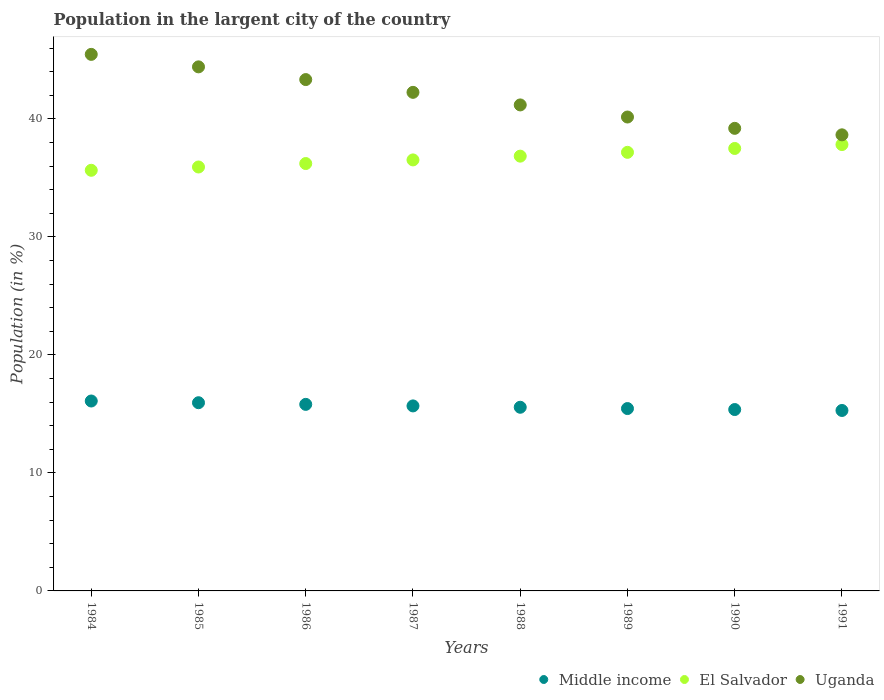What is the percentage of population in the largent city in Middle income in 1987?
Ensure brevity in your answer.  15.68. Across all years, what is the maximum percentage of population in the largent city in Middle income?
Your response must be concise. 16.1. Across all years, what is the minimum percentage of population in the largent city in Uganda?
Offer a very short reply. 38.65. In which year was the percentage of population in the largent city in El Salvador minimum?
Offer a terse response. 1984. What is the total percentage of population in the largent city in Uganda in the graph?
Ensure brevity in your answer.  334.69. What is the difference between the percentage of population in the largent city in El Salvador in 1984 and that in 1990?
Your answer should be very brief. -1.85. What is the difference between the percentage of population in the largent city in Uganda in 1984 and the percentage of population in the largent city in Middle income in 1988?
Make the answer very short. 29.91. What is the average percentage of population in the largent city in Uganda per year?
Give a very brief answer. 41.84. In the year 1987, what is the difference between the percentage of population in the largent city in Uganda and percentage of population in the largent city in Middle income?
Give a very brief answer. 26.57. What is the ratio of the percentage of population in the largent city in Uganda in 1985 to that in 1989?
Make the answer very short. 1.11. What is the difference between the highest and the second highest percentage of population in the largent city in El Salvador?
Offer a terse response. 0.33. What is the difference between the highest and the lowest percentage of population in the largent city in Uganda?
Your response must be concise. 6.82. In how many years, is the percentage of population in the largent city in El Salvador greater than the average percentage of population in the largent city in El Salvador taken over all years?
Ensure brevity in your answer.  4. How many years are there in the graph?
Make the answer very short. 8. What is the difference between two consecutive major ticks on the Y-axis?
Offer a very short reply. 10. Does the graph contain any zero values?
Your answer should be compact. No. Does the graph contain grids?
Offer a terse response. No. Where does the legend appear in the graph?
Offer a very short reply. Bottom right. How many legend labels are there?
Keep it short and to the point. 3. What is the title of the graph?
Your answer should be compact. Population in the largent city of the country. What is the Population (in %) in Middle income in 1984?
Provide a succinct answer. 16.1. What is the Population (in %) of El Salvador in 1984?
Offer a terse response. 35.65. What is the Population (in %) of Uganda in 1984?
Offer a terse response. 45.47. What is the Population (in %) in Middle income in 1985?
Provide a short and direct response. 15.95. What is the Population (in %) in El Salvador in 1985?
Give a very brief answer. 35.93. What is the Population (in %) of Uganda in 1985?
Offer a terse response. 44.41. What is the Population (in %) in Middle income in 1986?
Ensure brevity in your answer.  15.81. What is the Population (in %) of El Salvador in 1986?
Offer a very short reply. 36.22. What is the Population (in %) of Uganda in 1986?
Keep it short and to the point. 43.34. What is the Population (in %) of Middle income in 1987?
Provide a short and direct response. 15.68. What is the Population (in %) in El Salvador in 1987?
Keep it short and to the point. 36.53. What is the Population (in %) of Uganda in 1987?
Make the answer very short. 42.25. What is the Population (in %) in Middle income in 1988?
Your answer should be compact. 15.57. What is the Population (in %) of El Salvador in 1988?
Keep it short and to the point. 36.85. What is the Population (in %) of Uganda in 1988?
Ensure brevity in your answer.  41.19. What is the Population (in %) of Middle income in 1989?
Provide a short and direct response. 15.46. What is the Population (in %) in El Salvador in 1989?
Your answer should be very brief. 37.17. What is the Population (in %) of Uganda in 1989?
Provide a succinct answer. 40.16. What is the Population (in %) of Middle income in 1990?
Your answer should be very brief. 15.37. What is the Population (in %) of El Salvador in 1990?
Your answer should be compact. 37.5. What is the Population (in %) in Uganda in 1990?
Give a very brief answer. 39.2. What is the Population (in %) in Middle income in 1991?
Offer a very short reply. 15.29. What is the Population (in %) in El Salvador in 1991?
Ensure brevity in your answer.  37.83. What is the Population (in %) of Uganda in 1991?
Offer a terse response. 38.65. Across all years, what is the maximum Population (in %) of Middle income?
Your answer should be very brief. 16.1. Across all years, what is the maximum Population (in %) in El Salvador?
Your answer should be very brief. 37.83. Across all years, what is the maximum Population (in %) in Uganda?
Provide a succinct answer. 45.47. Across all years, what is the minimum Population (in %) in Middle income?
Offer a very short reply. 15.29. Across all years, what is the minimum Population (in %) of El Salvador?
Your answer should be compact. 35.65. Across all years, what is the minimum Population (in %) in Uganda?
Offer a very short reply. 38.65. What is the total Population (in %) in Middle income in the graph?
Offer a very short reply. 125.22. What is the total Population (in %) of El Salvador in the graph?
Provide a succinct answer. 293.67. What is the total Population (in %) of Uganda in the graph?
Ensure brevity in your answer.  334.69. What is the difference between the Population (in %) in Middle income in 1984 and that in 1985?
Offer a very short reply. 0.14. What is the difference between the Population (in %) in El Salvador in 1984 and that in 1985?
Offer a very short reply. -0.28. What is the difference between the Population (in %) in Uganda in 1984 and that in 1985?
Give a very brief answer. 1.06. What is the difference between the Population (in %) of Middle income in 1984 and that in 1986?
Give a very brief answer. 0.28. What is the difference between the Population (in %) in El Salvador in 1984 and that in 1986?
Provide a succinct answer. -0.57. What is the difference between the Population (in %) in Uganda in 1984 and that in 1986?
Provide a succinct answer. 2.14. What is the difference between the Population (in %) in Middle income in 1984 and that in 1987?
Keep it short and to the point. 0.42. What is the difference between the Population (in %) of El Salvador in 1984 and that in 1987?
Ensure brevity in your answer.  -0.88. What is the difference between the Population (in %) in Uganda in 1984 and that in 1987?
Keep it short and to the point. 3.22. What is the difference between the Population (in %) in Middle income in 1984 and that in 1988?
Offer a very short reply. 0.53. What is the difference between the Population (in %) of El Salvador in 1984 and that in 1988?
Provide a short and direct response. -1.2. What is the difference between the Population (in %) of Uganda in 1984 and that in 1988?
Your answer should be compact. 4.28. What is the difference between the Population (in %) in Middle income in 1984 and that in 1989?
Provide a short and direct response. 0.64. What is the difference between the Population (in %) of El Salvador in 1984 and that in 1989?
Give a very brief answer. -1.52. What is the difference between the Population (in %) of Uganda in 1984 and that in 1989?
Offer a very short reply. 5.31. What is the difference between the Population (in %) in Middle income in 1984 and that in 1990?
Offer a terse response. 0.72. What is the difference between the Population (in %) in El Salvador in 1984 and that in 1990?
Make the answer very short. -1.85. What is the difference between the Population (in %) of Uganda in 1984 and that in 1990?
Give a very brief answer. 6.27. What is the difference between the Population (in %) of Middle income in 1984 and that in 1991?
Ensure brevity in your answer.  0.8. What is the difference between the Population (in %) of El Salvador in 1984 and that in 1991?
Ensure brevity in your answer.  -2.18. What is the difference between the Population (in %) of Uganda in 1984 and that in 1991?
Give a very brief answer. 6.82. What is the difference between the Population (in %) in Middle income in 1985 and that in 1986?
Offer a very short reply. 0.14. What is the difference between the Population (in %) in El Salvador in 1985 and that in 1986?
Your answer should be compact. -0.29. What is the difference between the Population (in %) of Uganda in 1985 and that in 1986?
Provide a succinct answer. 1.08. What is the difference between the Population (in %) of Middle income in 1985 and that in 1987?
Make the answer very short. 0.27. What is the difference between the Population (in %) in El Salvador in 1985 and that in 1987?
Ensure brevity in your answer.  -0.6. What is the difference between the Population (in %) of Uganda in 1985 and that in 1987?
Offer a terse response. 2.16. What is the difference between the Population (in %) in Middle income in 1985 and that in 1988?
Your answer should be compact. 0.38. What is the difference between the Population (in %) of El Salvador in 1985 and that in 1988?
Keep it short and to the point. -0.92. What is the difference between the Population (in %) in Uganda in 1985 and that in 1988?
Give a very brief answer. 3.23. What is the difference between the Population (in %) in Middle income in 1985 and that in 1989?
Provide a succinct answer. 0.49. What is the difference between the Population (in %) of El Salvador in 1985 and that in 1989?
Provide a short and direct response. -1.24. What is the difference between the Population (in %) in Uganda in 1985 and that in 1989?
Your answer should be compact. 4.25. What is the difference between the Population (in %) of Middle income in 1985 and that in 1990?
Make the answer very short. 0.58. What is the difference between the Population (in %) in El Salvador in 1985 and that in 1990?
Offer a very short reply. -1.57. What is the difference between the Population (in %) in Uganda in 1985 and that in 1990?
Keep it short and to the point. 5.21. What is the difference between the Population (in %) in Middle income in 1985 and that in 1991?
Offer a terse response. 0.66. What is the difference between the Population (in %) of El Salvador in 1985 and that in 1991?
Provide a short and direct response. -1.9. What is the difference between the Population (in %) of Uganda in 1985 and that in 1991?
Ensure brevity in your answer.  5.76. What is the difference between the Population (in %) of Middle income in 1986 and that in 1987?
Provide a succinct answer. 0.13. What is the difference between the Population (in %) of El Salvador in 1986 and that in 1987?
Provide a succinct answer. -0.31. What is the difference between the Population (in %) in Uganda in 1986 and that in 1987?
Keep it short and to the point. 1.08. What is the difference between the Population (in %) of Middle income in 1986 and that in 1988?
Provide a succinct answer. 0.24. What is the difference between the Population (in %) in El Salvador in 1986 and that in 1988?
Offer a terse response. -0.63. What is the difference between the Population (in %) of Uganda in 1986 and that in 1988?
Keep it short and to the point. 2.15. What is the difference between the Population (in %) of Middle income in 1986 and that in 1989?
Make the answer very short. 0.35. What is the difference between the Population (in %) of El Salvador in 1986 and that in 1989?
Make the answer very short. -0.95. What is the difference between the Population (in %) in Uganda in 1986 and that in 1989?
Your answer should be compact. 3.17. What is the difference between the Population (in %) in Middle income in 1986 and that in 1990?
Your answer should be very brief. 0.44. What is the difference between the Population (in %) of El Salvador in 1986 and that in 1990?
Your answer should be very brief. -1.28. What is the difference between the Population (in %) in Uganda in 1986 and that in 1990?
Make the answer very short. 4.13. What is the difference between the Population (in %) in Middle income in 1986 and that in 1991?
Offer a very short reply. 0.52. What is the difference between the Population (in %) in El Salvador in 1986 and that in 1991?
Provide a short and direct response. -1.61. What is the difference between the Population (in %) in Uganda in 1986 and that in 1991?
Provide a succinct answer. 4.68. What is the difference between the Population (in %) of Middle income in 1987 and that in 1988?
Your response must be concise. 0.11. What is the difference between the Population (in %) in El Salvador in 1987 and that in 1988?
Provide a succinct answer. -0.32. What is the difference between the Population (in %) in Uganda in 1987 and that in 1988?
Provide a succinct answer. 1.07. What is the difference between the Population (in %) of Middle income in 1987 and that in 1989?
Keep it short and to the point. 0.22. What is the difference between the Population (in %) in El Salvador in 1987 and that in 1989?
Provide a short and direct response. -0.64. What is the difference between the Population (in %) in Uganda in 1987 and that in 1989?
Your answer should be compact. 2.09. What is the difference between the Population (in %) in Middle income in 1987 and that in 1990?
Your response must be concise. 0.31. What is the difference between the Population (in %) in El Salvador in 1987 and that in 1990?
Ensure brevity in your answer.  -0.97. What is the difference between the Population (in %) in Uganda in 1987 and that in 1990?
Ensure brevity in your answer.  3.05. What is the difference between the Population (in %) in Middle income in 1987 and that in 1991?
Provide a short and direct response. 0.39. What is the difference between the Population (in %) in El Salvador in 1987 and that in 1991?
Your answer should be very brief. -1.3. What is the difference between the Population (in %) of Uganda in 1987 and that in 1991?
Your response must be concise. 3.6. What is the difference between the Population (in %) in Middle income in 1988 and that in 1989?
Provide a succinct answer. 0.11. What is the difference between the Population (in %) in El Salvador in 1988 and that in 1989?
Your answer should be very brief. -0.32. What is the difference between the Population (in %) in Uganda in 1988 and that in 1989?
Ensure brevity in your answer.  1.02. What is the difference between the Population (in %) in Middle income in 1988 and that in 1990?
Provide a short and direct response. 0.19. What is the difference between the Population (in %) in El Salvador in 1988 and that in 1990?
Offer a very short reply. -0.65. What is the difference between the Population (in %) in Uganda in 1988 and that in 1990?
Make the answer very short. 1.98. What is the difference between the Population (in %) in Middle income in 1988 and that in 1991?
Ensure brevity in your answer.  0.27. What is the difference between the Population (in %) in El Salvador in 1988 and that in 1991?
Make the answer very short. -0.98. What is the difference between the Population (in %) in Uganda in 1988 and that in 1991?
Provide a succinct answer. 2.53. What is the difference between the Population (in %) of Middle income in 1989 and that in 1990?
Your response must be concise. 0.08. What is the difference between the Population (in %) of El Salvador in 1989 and that in 1990?
Ensure brevity in your answer.  -0.33. What is the difference between the Population (in %) in Uganda in 1989 and that in 1990?
Provide a succinct answer. 0.96. What is the difference between the Population (in %) of Middle income in 1989 and that in 1991?
Ensure brevity in your answer.  0.16. What is the difference between the Population (in %) of El Salvador in 1989 and that in 1991?
Your answer should be very brief. -0.66. What is the difference between the Population (in %) in Uganda in 1989 and that in 1991?
Your answer should be very brief. 1.51. What is the difference between the Population (in %) of Middle income in 1990 and that in 1991?
Your answer should be compact. 0.08. What is the difference between the Population (in %) in El Salvador in 1990 and that in 1991?
Give a very brief answer. -0.33. What is the difference between the Population (in %) of Uganda in 1990 and that in 1991?
Make the answer very short. 0.55. What is the difference between the Population (in %) of Middle income in 1984 and the Population (in %) of El Salvador in 1985?
Your response must be concise. -19.83. What is the difference between the Population (in %) of Middle income in 1984 and the Population (in %) of Uganda in 1985?
Keep it short and to the point. -28.32. What is the difference between the Population (in %) of El Salvador in 1984 and the Population (in %) of Uganda in 1985?
Make the answer very short. -8.77. What is the difference between the Population (in %) of Middle income in 1984 and the Population (in %) of El Salvador in 1986?
Offer a terse response. -20.13. What is the difference between the Population (in %) of Middle income in 1984 and the Population (in %) of Uganda in 1986?
Offer a very short reply. -27.24. What is the difference between the Population (in %) of El Salvador in 1984 and the Population (in %) of Uganda in 1986?
Provide a short and direct response. -7.69. What is the difference between the Population (in %) of Middle income in 1984 and the Population (in %) of El Salvador in 1987?
Provide a short and direct response. -20.43. What is the difference between the Population (in %) of Middle income in 1984 and the Population (in %) of Uganda in 1987?
Provide a short and direct response. -26.16. What is the difference between the Population (in %) of El Salvador in 1984 and the Population (in %) of Uganda in 1987?
Provide a short and direct response. -6.61. What is the difference between the Population (in %) of Middle income in 1984 and the Population (in %) of El Salvador in 1988?
Your answer should be compact. -20.75. What is the difference between the Population (in %) of Middle income in 1984 and the Population (in %) of Uganda in 1988?
Offer a very short reply. -25.09. What is the difference between the Population (in %) of El Salvador in 1984 and the Population (in %) of Uganda in 1988?
Your response must be concise. -5.54. What is the difference between the Population (in %) of Middle income in 1984 and the Population (in %) of El Salvador in 1989?
Your response must be concise. -21.08. What is the difference between the Population (in %) of Middle income in 1984 and the Population (in %) of Uganda in 1989?
Ensure brevity in your answer.  -24.07. What is the difference between the Population (in %) in El Salvador in 1984 and the Population (in %) in Uganda in 1989?
Your response must be concise. -4.51. What is the difference between the Population (in %) of Middle income in 1984 and the Population (in %) of El Salvador in 1990?
Provide a succinct answer. -21.4. What is the difference between the Population (in %) in Middle income in 1984 and the Population (in %) in Uganda in 1990?
Your response must be concise. -23.11. What is the difference between the Population (in %) in El Salvador in 1984 and the Population (in %) in Uganda in 1990?
Ensure brevity in your answer.  -3.56. What is the difference between the Population (in %) of Middle income in 1984 and the Population (in %) of El Salvador in 1991?
Offer a very short reply. -21.73. What is the difference between the Population (in %) of Middle income in 1984 and the Population (in %) of Uganda in 1991?
Your answer should be very brief. -22.56. What is the difference between the Population (in %) of El Salvador in 1984 and the Population (in %) of Uganda in 1991?
Provide a succinct answer. -3.01. What is the difference between the Population (in %) of Middle income in 1985 and the Population (in %) of El Salvador in 1986?
Offer a terse response. -20.27. What is the difference between the Population (in %) in Middle income in 1985 and the Population (in %) in Uganda in 1986?
Your answer should be very brief. -27.39. What is the difference between the Population (in %) of El Salvador in 1985 and the Population (in %) of Uganda in 1986?
Offer a terse response. -7.41. What is the difference between the Population (in %) of Middle income in 1985 and the Population (in %) of El Salvador in 1987?
Provide a short and direct response. -20.58. What is the difference between the Population (in %) in Middle income in 1985 and the Population (in %) in Uganda in 1987?
Provide a short and direct response. -26.3. What is the difference between the Population (in %) in El Salvador in 1985 and the Population (in %) in Uganda in 1987?
Offer a terse response. -6.33. What is the difference between the Population (in %) of Middle income in 1985 and the Population (in %) of El Salvador in 1988?
Give a very brief answer. -20.9. What is the difference between the Population (in %) of Middle income in 1985 and the Population (in %) of Uganda in 1988?
Offer a very short reply. -25.24. What is the difference between the Population (in %) of El Salvador in 1985 and the Population (in %) of Uganda in 1988?
Provide a succinct answer. -5.26. What is the difference between the Population (in %) of Middle income in 1985 and the Population (in %) of El Salvador in 1989?
Your answer should be compact. -21.22. What is the difference between the Population (in %) in Middle income in 1985 and the Population (in %) in Uganda in 1989?
Offer a terse response. -24.21. What is the difference between the Population (in %) in El Salvador in 1985 and the Population (in %) in Uganda in 1989?
Make the answer very short. -4.24. What is the difference between the Population (in %) of Middle income in 1985 and the Population (in %) of El Salvador in 1990?
Provide a short and direct response. -21.55. What is the difference between the Population (in %) in Middle income in 1985 and the Population (in %) in Uganda in 1990?
Make the answer very short. -23.25. What is the difference between the Population (in %) in El Salvador in 1985 and the Population (in %) in Uganda in 1990?
Provide a succinct answer. -3.28. What is the difference between the Population (in %) of Middle income in 1985 and the Population (in %) of El Salvador in 1991?
Provide a short and direct response. -21.88. What is the difference between the Population (in %) in Middle income in 1985 and the Population (in %) in Uganda in 1991?
Provide a succinct answer. -22.7. What is the difference between the Population (in %) of El Salvador in 1985 and the Population (in %) of Uganda in 1991?
Give a very brief answer. -2.73. What is the difference between the Population (in %) of Middle income in 1986 and the Population (in %) of El Salvador in 1987?
Provide a short and direct response. -20.72. What is the difference between the Population (in %) of Middle income in 1986 and the Population (in %) of Uganda in 1987?
Offer a very short reply. -26.44. What is the difference between the Population (in %) in El Salvador in 1986 and the Population (in %) in Uganda in 1987?
Give a very brief answer. -6.03. What is the difference between the Population (in %) in Middle income in 1986 and the Population (in %) in El Salvador in 1988?
Offer a very short reply. -21.04. What is the difference between the Population (in %) in Middle income in 1986 and the Population (in %) in Uganda in 1988?
Offer a very short reply. -25.38. What is the difference between the Population (in %) in El Salvador in 1986 and the Population (in %) in Uganda in 1988?
Offer a very short reply. -4.97. What is the difference between the Population (in %) in Middle income in 1986 and the Population (in %) in El Salvador in 1989?
Give a very brief answer. -21.36. What is the difference between the Population (in %) in Middle income in 1986 and the Population (in %) in Uganda in 1989?
Keep it short and to the point. -24.35. What is the difference between the Population (in %) in El Salvador in 1986 and the Population (in %) in Uganda in 1989?
Ensure brevity in your answer.  -3.94. What is the difference between the Population (in %) in Middle income in 1986 and the Population (in %) in El Salvador in 1990?
Your answer should be very brief. -21.69. What is the difference between the Population (in %) in Middle income in 1986 and the Population (in %) in Uganda in 1990?
Your answer should be very brief. -23.39. What is the difference between the Population (in %) in El Salvador in 1986 and the Population (in %) in Uganda in 1990?
Keep it short and to the point. -2.98. What is the difference between the Population (in %) of Middle income in 1986 and the Population (in %) of El Salvador in 1991?
Your answer should be compact. -22.02. What is the difference between the Population (in %) of Middle income in 1986 and the Population (in %) of Uganda in 1991?
Offer a terse response. -22.84. What is the difference between the Population (in %) of El Salvador in 1986 and the Population (in %) of Uganda in 1991?
Keep it short and to the point. -2.43. What is the difference between the Population (in %) in Middle income in 1987 and the Population (in %) in El Salvador in 1988?
Your response must be concise. -21.17. What is the difference between the Population (in %) of Middle income in 1987 and the Population (in %) of Uganda in 1988?
Offer a very short reply. -25.51. What is the difference between the Population (in %) in El Salvador in 1987 and the Population (in %) in Uganda in 1988?
Make the answer very short. -4.66. What is the difference between the Population (in %) in Middle income in 1987 and the Population (in %) in El Salvador in 1989?
Your answer should be very brief. -21.49. What is the difference between the Population (in %) of Middle income in 1987 and the Population (in %) of Uganda in 1989?
Your answer should be compact. -24.48. What is the difference between the Population (in %) in El Salvador in 1987 and the Population (in %) in Uganda in 1989?
Provide a succinct answer. -3.64. What is the difference between the Population (in %) of Middle income in 1987 and the Population (in %) of El Salvador in 1990?
Offer a very short reply. -21.82. What is the difference between the Population (in %) of Middle income in 1987 and the Population (in %) of Uganda in 1990?
Keep it short and to the point. -23.52. What is the difference between the Population (in %) of El Salvador in 1987 and the Population (in %) of Uganda in 1990?
Your answer should be compact. -2.68. What is the difference between the Population (in %) of Middle income in 1987 and the Population (in %) of El Salvador in 1991?
Your response must be concise. -22.15. What is the difference between the Population (in %) in Middle income in 1987 and the Population (in %) in Uganda in 1991?
Keep it short and to the point. -22.97. What is the difference between the Population (in %) in El Salvador in 1987 and the Population (in %) in Uganda in 1991?
Make the answer very short. -2.13. What is the difference between the Population (in %) of Middle income in 1988 and the Population (in %) of El Salvador in 1989?
Keep it short and to the point. -21.6. What is the difference between the Population (in %) of Middle income in 1988 and the Population (in %) of Uganda in 1989?
Provide a succinct answer. -24.6. What is the difference between the Population (in %) of El Salvador in 1988 and the Population (in %) of Uganda in 1989?
Provide a short and direct response. -3.32. What is the difference between the Population (in %) of Middle income in 1988 and the Population (in %) of El Salvador in 1990?
Your answer should be compact. -21.93. What is the difference between the Population (in %) in Middle income in 1988 and the Population (in %) in Uganda in 1990?
Offer a terse response. -23.64. What is the difference between the Population (in %) in El Salvador in 1988 and the Population (in %) in Uganda in 1990?
Offer a terse response. -2.36. What is the difference between the Population (in %) of Middle income in 1988 and the Population (in %) of El Salvador in 1991?
Make the answer very short. -22.26. What is the difference between the Population (in %) in Middle income in 1988 and the Population (in %) in Uganda in 1991?
Ensure brevity in your answer.  -23.09. What is the difference between the Population (in %) of El Salvador in 1988 and the Population (in %) of Uganda in 1991?
Provide a succinct answer. -1.81. What is the difference between the Population (in %) of Middle income in 1989 and the Population (in %) of El Salvador in 1990?
Offer a very short reply. -22.04. What is the difference between the Population (in %) in Middle income in 1989 and the Population (in %) in Uganda in 1990?
Your answer should be very brief. -23.75. What is the difference between the Population (in %) of El Salvador in 1989 and the Population (in %) of Uganda in 1990?
Provide a short and direct response. -2.03. What is the difference between the Population (in %) in Middle income in 1989 and the Population (in %) in El Salvador in 1991?
Provide a short and direct response. -22.37. What is the difference between the Population (in %) of Middle income in 1989 and the Population (in %) of Uganda in 1991?
Ensure brevity in your answer.  -23.2. What is the difference between the Population (in %) in El Salvador in 1989 and the Population (in %) in Uganda in 1991?
Your answer should be compact. -1.48. What is the difference between the Population (in %) in Middle income in 1990 and the Population (in %) in El Salvador in 1991?
Keep it short and to the point. -22.46. What is the difference between the Population (in %) of Middle income in 1990 and the Population (in %) of Uganda in 1991?
Provide a short and direct response. -23.28. What is the difference between the Population (in %) in El Salvador in 1990 and the Population (in %) in Uganda in 1991?
Your answer should be very brief. -1.15. What is the average Population (in %) in Middle income per year?
Your answer should be very brief. 15.65. What is the average Population (in %) in El Salvador per year?
Make the answer very short. 36.71. What is the average Population (in %) of Uganda per year?
Your answer should be compact. 41.84. In the year 1984, what is the difference between the Population (in %) of Middle income and Population (in %) of El Salvador?
Your response must be concise. -19.55. In the year 1984, what is the difference between the Population (in %) in Middle income and Population (in %) in Uganda?
Provide a short and direct response. -29.38. In the year 1984, what is the difference between the Population (in %) of El Salvador and Population (in %) of Uganda?
Offer a terse response. -9.82. In the year 1985, what is the difference between the Population (in %) of Middle income and Population (in %) of El Salvador?
Make the answer very short. -19.98. In the year 1985, what is the difference between the Population (in %) of Middle income and Population (in %) of Uganda?
Offer a very short reply. -28.46. In the year 1985, what is the difference between the Population (in %) of El Salvador and Population (in %) of Uganda?
Give a very brief answer. -8.49. In the year 1986, what is the difference between the Population (in %) of Middle income and Population (in %) of El Salvador?
Provide a succinct answer. -20.41. In the year 1986, what is the difference between the Population (in %) of Middle income and Population (in %) of Uganda?
Your answer should be compact. -27.53. In the year 1986, what is the difference between the Population (in %) of El Salvador and Population (in %) of Uganda?
Provide a short and direct response. -7.12. In the year 1987, what is the difference between the Population (in %) in Middle income and Population (in %) in El Salvador?
Your answer should be very brief. -20.85. In the year 1987, what is the difference between the Population (in %) in Middle income and Population (in %) in Uganda?
Offer a terse response. -26.57. In the year 1987, what is the difference between the Population (in %) in El Salvador and Population (in %) in Uganda?
Your answer should be very brief. -5.73. In the year 1988, what is the difference between the Population (in %) of Middle income and Population (in %) of El Salvador?
Your answer should be compact. -21.28. In the year 1988, what is the difference between the Population (in %) of Middle income and Population (in %) of Uganda?
Your response must be concise. -25.62. In the year 1988, what is the difference between the Population (in %) of El Salvador and Population (in %) of Uganda?
Offer a very short reply. -4.34. In the year 1989, what is the difference between the Population (in %) in Middle income and Population (in %) in El Salvador?
Ensure brevity in your answer.  -21.71. In the year 1989, what is the difference between the Population (in %) in Middle income and Population (in %) in Uganda?
Make the answer very short. -24.71. In the year 1989, what is the difference between the Population (in %) of El Salvador and Population (in %) of Uganda?
Your answer should be compact. -2.99. In the year 1990, what is the difference between the Population (in %) of Middle income and Population (in %) of El Salvador?
Provide a succinct answer. -22.13. In the year 1990, what is the difference between the Population (in %) in Middle income and Population (in %) in Uganda?
Your response must be concise. -23.83. In the year 1990, what is the difference between the Population (in %) in El Salvador and Population (in %) in Uganda?
Your answer should be compact. -1.7. In the year 1991, what is the difference between the Population (in %) of Middle income and Population (in %) of El Salvador?
Provide a short and direct response. -22.54. In the year 1991, what is the difference between the Population (in %) in Middle income and Population (in %) in Uganda?
Provide a short and direct response. -23.36. In the year 1991, what is the difference between the Population (in %) of El Salvador and Population (in %) of Uganda?
Give a very brief answer. -0.82. What is the ratio of the Population (in %) in Middle income in 1984 to that in 1985?
Offer a very short reply. 1.01. What is the ratio of the Population (in %) of El Salvador in 1984 to that in 1985?
Keep it short and to the point. 0.99. What is the ratio of the Population (in %) in Uganda in 1984 to that in 1985?
Make the answer very short. 1.02. What is the ratio of the Population (in %) in El Salvador in 1984 to that in 1986?
Your answer should be compact. 0.98. What is the ratio of the Population (in %) in Uganda in 1984 to that in 1986?
Keep it short and to the point. 1.05. What is the ratio of the Population (in %) in Middle income in 1984 to that in 1987?
Ensure brevity in your answer.  1.03. What is the ratio of the Population (in %) of El Salvador in 1984 to that in 1987?
Offer a terse response. 0.98. What is the ratio of the Population (in %) in Uganda in 1984 to that in 1987?
Your answer should be compact. 1.08. What is the ratio of the Population (in %) of Middle income in 1984 to that in 1988?
Provide a succinct answer. 1.03. What is the ratio of the Population (in %) of El Salvador in 1984 to that in 1988?
Provide a succinct answer. 0.97. What is the ratio of the Population (in %) of Uganda in 1984 to that in 1988?
Ensure brevity in your answer.  1.1. What is the ratio of the Population (in %) of Middle income in 1984 to that in 1989?
Ensure brevity in your answer.  1.04. What is the ratio of the Population (in %) in El Salvador in 1984 to that in 1989?
Provide a short and direct response. 0.96. What is the ratio of the Population (in %) in Uganda in 1984 to that in 1989?
Your response must be concise. 1.13. What is the ratio of the Population (in %) in Middle income in 1984 to that in 1990?
Provide a short and direct response. 1.05. What is the ratio of the Population (in %) in El Salvador in 1984 to that in 1990?
Offer a very short reply. 0.95. What is the ratio of the Population (in %) of Uganda in 1984 to that in 1990?
Make the answer very short. 1.16. What is the ratio of the Population (in %) in Middle income in 1984 to that in 1991?
Provide a succinct answer. 1.05. What is the ratio of the Population (in %) of El Salvador in 1984 to that in 1991?
Your answer should be very brief. 0.94. What is the ratio of the Population (in %) of Uganda in 1984 to that in 1991?
Your response must be concise. 1.18. What is the ratio of the Population (in %) of Middle income in 1985 to that in 1986?
Your response must be concise. 1.01. What is the ratio of the Population (in %) of Uganda in 1985 to that in 1986?
Your response must be concise. 1.02. What is the ratio of the Population (in %) of Middle income in 1985 to that in 1987?
Give a very brief answer. 1.02. What is the ratio of the Population (in %) of El Salvador in 1985 to that in 1987?
Offer a terse response. 0.98. What is the ratio of the Population (in %) of Uganda in 1985 to that in 1987?
Provide a succinct answer. 1.05. What is the ratio of the Population (in %) of Middle income in 1985 to that in 1988?
Offer a very short reply. 1.02. What is the ratio of the Population (in %) of Uganda in 1985 to that in 1988?
Make the answer very short. 1.08. What is the ratio of the Population (in %) of Middle income in 1985 to that in 1989?
Offer a very short reply. 1.03. What is the ratio of the Population (in %) of El Salvador in 1985 to that in 1989?
Keep it short and to the point. 0.97. What is the ratio of the Population (in %) of Uganda in 1985 to that in 1989?
Your answer should be compact. 1.11. What is the ratio of the Population (in %) of Middle income in 1985 to that in 1990?
Provide a succinct answer. 1.04. What is the ratio of the Population (in %) of El Salvador in 1985 to that in 1990?
Keep it short and to the point. 0.96. What is the ratio of the Population (in %) of Uganda in 1985 to that in 1990?
Give a very brief answer. 1.13. What is the ratio of the Population (in %) in Middle income in 1985 to that in 1991?
Keep it short and to the point. 1.04. What is the ratio of the Population (in %) in El Salvador in 1985 to that in 1991?
Offer a very short reply. 0.95. What is the ratio of the Population (in %) in Uganda in 1985 to that in 1991?
Your response must be concise. 1.15. What is the ratio of the Population (in %) in Middle income in 1986 to that in 1987?
Your answer should be compact. 1.01. What is the ratio of the Population (in %) in Uganda in 1986 to that in 1987?
Give a very brief answer. 1.03. What is the ratio of the Population (in %) in Middle income in 1986 to that in 1988?
Your response must be concise. 1.02. What is the ratio of the Population (in %) of Uganda in 1986 to that in 1988?
Give a very brief answer. 1.05. What is the ratio of the Population (in %) in Middle income in 1986 to that in 1989?
Offer a terse response. 1.02. What is the ratio of the Population (in %) in El Salvador in 1986 to that in 1989?
Your response must be concise. 0.97. What is the ratio of the Population (in %) of Uganda in 1986 to that in 1989?
Your response must be concise. 1.08. What is the ratio of the Population (in %) of Middle income in 1986 to that in 1990?
Keep it short and to the point. 1.03. What is the ratio of the Population (in %) in El Salvador in 1986 to that in 1990?
Ensure brevity in your answer.  0.97. What is the ratio of the Population (in %) of Uganda in 1986 to that in 1990?
Provide a short and direct response. 1.11. What is the ratio of the Population (in %) in Middle income in 1986 to that in 1991?
Give a very brief answer. 1.03. What is the ratio of the Population (in %) of El Salvador in 1986 to that in 1991?
Your response must be concise. 0.96. What is the ratio of the Population (in %) in Uganda in 1986 to that in 1991?
Provide a short and direct response. 1.12. What is the ratio of the Population (in %) in Middle income in 1987 to that in 1988?
Make the answer very short. 1.01. What is the ratio of the Population (in %) in El Salvador in 1987 to that in 1988?
Provide a succinct answer. 0.99. What is the ratio of the Population (in %) in Uganda in 1987 to that in 1988?
Your response must be concise. 1.03. What is the ratio of the Population (in %) in Middle income in 1987 to that in 1989?
Make the answer very short. 1.01. What is the ratio of the Population (in %) in El Salvador in 1987 to that in 1989?
Offer a very short reply. 0.98. What is the ratio of the Population (in %) of Uganda in 1987 to that in 1989?
Ensure brevity in your answer.  1.05. What is the ratio of the Population (in %) in El Salvador in 1987 to that in 1990?
Give a very brief answer. 0.97. What is the ratio of the Population (in %) of Uganda in 1987 to that in 1990?
Keep it short and to the point. 1.08. What is the ratio of the Population (in %) of Middle income in 1987 to that in 1991?
Your answer should be very brief. 1.03. What is the ratio of the Population (in %) in El Salvador in 1987 to that in 1991?
Your response must be concise. 0.97. What is the ratio of the Population (in %) in Uganda in 1987 to that in 1991?
Offer a very short reply. 1.09. What is the ratio of the Population (in %) of Middle income in 1988 to that in 1989?
Provide a succinct answer. 1.01. What is the ratio of the Population (in %) in Uganda in 1988 to that in 1989?
Your answer should be compact. 1.03. What is the ratio of the Population (in %) of Middle income in 1988 to that in 1990?
Your answer should be compact. 1.01. What is the ratio of the Population (in %) of El Salvador in 1988 to that in 1990?
Your response must be concise. 0.98. What is the ratio of the Population (in %) of Uganda in 1988 to that in 1990?
Offer a terse response. 1.05. What is the ratio of the Population (in %) in Middle income in 1988 to that in 1991?
Make the answer very short. 1.02. What is the ratio of the Population (in %) in El Salvador in 1988 to that in 1991?
Give a very brief answer. 0.97. What is the ratio of the Population (in %) of Uganda in 1988 to that in 1991?
Offer a terse response. 1.07. What is the ratio of the Population (in %) in Middle income in 1989 to that in 1990?
Your answer should be very brief. 1.01. What is the ratio of the Population (in %) of Uganda in 1989 to that in 1990?
Give a very brief answer. 1.02. What is the ratio of the Population (in %) in Middle income in 1989 to that in 1991?
Offer a very short reply. 1.01. What is the ratio of the Population (in %) of El Salvador in 1989 to that in 1991?
Your answer should be compact. 0.98. What is the ratio of the Population (in %) of Uganda in 1989 to that in 1991?
Keep it short and to the point. 1.04. What is the ratio of the Population (in %) of Middle income in 1990 to that in 1991?
Provide a succinct answer. 1.01. What is the ratio of the Population (in %) in El Salvador in 1990 to that in 1991?
Provide a succinct answer. 0.99. What is the ratio of the Population (in %) in Uganda in 1990 to that in 1991?
Offer a terse response. 1.01. What is the difference between the highest and the second highest Population (in %) in Middle income?
Ensure brevity in your answer.  0.14. What is the difference between the highest and the second highest Population (in %) of El Salvador?
Your answer should be very brief. 0.33. What is the difference between the highest and the second highest Population (in %) in Uganda?
Provide a short and direct response. 1.06. What is the difference between the highest and the lowest Population (in %) in Middle income?
Make the answer very short. 0.8. What is the difference between the highest and the lowest Population (in %) in El Salvador?
Keep it short and to the point. 2.18. What is the difference between the highest and the lowest Population (in %) in Uganda?
Provide a short and direct response. 6.82. 